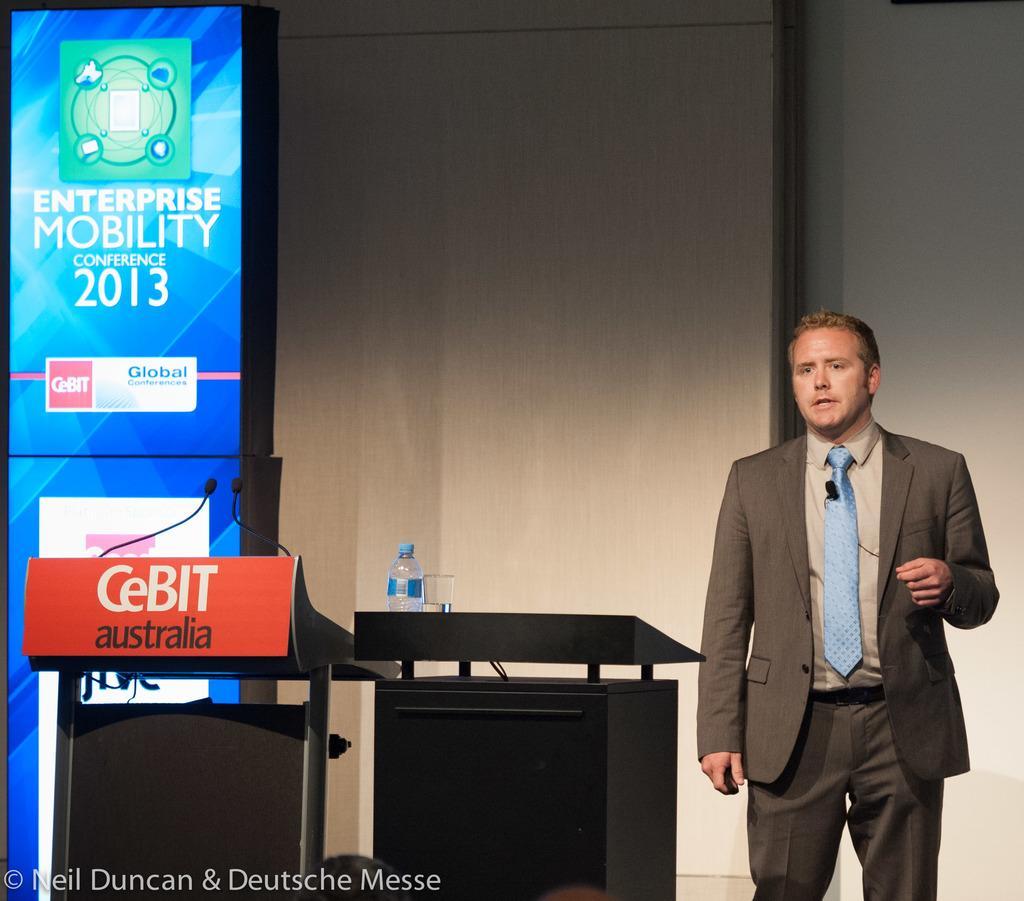How would you summarize this image in a sentence or two? In this image in the right a person is standing wearing grey suit and tie. Beside him there is a podium. On the podium there is a bottle. In the left there are two mics on a stand. In the background there is screen. 